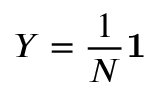Convert formula to latex. <formula><loc_0><loc_0><loc_500><loc_500>Y = { \frac { 1 } { N } } 1</formula> 